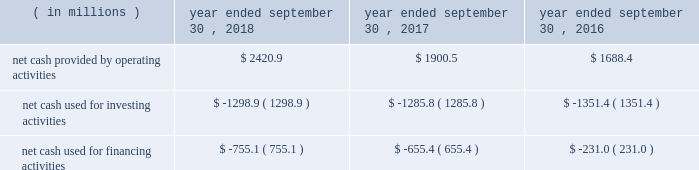Compared to earlier levels .
The pre-tax non-cash impairments of certain mineral rights and real estate discussed above under the caption fffdland and development impairments fffd are not included in segment income .
Liquidity and capital resources on january 29 , 2018 , we announced that a definitive agreement had been signed for us to acquire all of the outstanding shares of kapstone for $ 35.00 per share and the assumption of approximately $ 1.36 billion in net debt , for a total enterprise value of approximately $ 4.9 billion .
In contemplation of the transaction , on march 6 , 2018 , we issued $ 600.0 million aggregate principal amount of 3.75% ( 3.75 % ) senior notes due 2025 and $ 600.0 million aggregate principal amount of 4.0% ( 4.0 % ) senior notes due 2028 in an unregistered offering pursuant to rule 144a and regulation s under the securities act of 1933 , as amended ( the fffdsecurities act fffd ) .
In addition , on march 7 , 2018 , we entered into the delayed draw credit facilities ( as hereinafter defined ) that provide for $ 3.8 billion of senior unsecured term loans .
On november 2 , 2018 , in connection with the closing of the kapstone acquisition , we drew upon the facility in full .
The proceeds of the delayed draw credit facilities ( as hereinafter defined ) and other sources of cash were used to pay the consideration for the kapstone acquisition , to repay certain existing indebtedness of kapstone and to pay fees and expenses incurred in connection with the kapstone acquisition .
We fund our working capital requirements , capital expenditures , mergers , acquisitions and investments , restructuring activities , dividends and stock repurchases from net cash provided by operating activities , borrowings under our credit facilities , proceeds from our new a/r sales agreement ( as hereinafter defined ) , proceeds from the sale of property , plant and equipment removed from service and proceeds received in connection with the issuance of debt and equity securities .
See fffdnote 13 .
Debt fffdtt of the notes to consolidated financial statements for additional information .
Funding for our domestic operations in the foreseeable future is expected to come from sources of liquidity within our domestic operations , including cash and cash equivalents , and available borrowings under our credit facilities .
As such , our foreign cash and cash equivalents are not expected to be a key source of liquidity to our domestic operations .
At september 30 , 2018 , excluding the delayed draw credit facilities , we had approximately $ 3.2 billion of availability under our committed credit facilities , primarily under our revolving credit facility , the majority of which matures on july 1 , 2022 .
This liquidity may be used to provide for ongoing working capital needs and for other general corporate purposes , including acquisitions , dividends and stock repurchases .
Certain restrictive covenants govern our maximum availability under the credit facilities .
We test and report our compliance with these covenants as required and we were in compliance with all of these covenants at september 30 , 2018 .
At september 30 , 2018 , we had $ 104.9 million of outstanding letters of credit not drawn cash and cash equivalents were $ 636.8 million at september 30 , 2018 and $ 298.1 million at september 30 , 2017 .
We used a significant portion of the cash and cash equivalents on hand at september 30 , 2018 in connection with the closing of the kapstone acquisition .
Approximately 20% ( 20 % ) of the cash and cash equivalents at september 30 , 2018 were held outside of the u.s .
At september 30 , 2018 , total debt was $ 6415.2 million , $ 740.7 million of which was current .
At september 30 , 2017 , total debt was $ 6554.8 million , $ 608.7 million of which was current .
Cash flow activityy .
Net cash provided by operating activities during fiscal 2018 increased $ 520.4 million from fiscal 2017 primarily due to higher cash earnings and lower cash taxes due to the impact of the tax act .
Net cash provided by operating activities during fiscal 2017 increased $ 212.1 million from fiscal 2016 primarily due to a $ 111.6 million net increase in cash flow from working capital changes plus higher after-tax cash proceeds from our land and development segment fffds accelerated monetization .
The changes in working capital in fiscal 2018 , 2017 and 2016 included a .
In 2018 , what percent of the net cash from operations is retained after financing and investing activities? 
Computations: ((2420.9 - (1298.9 + 755.1)) / 2420.9)
Answer: 0.15156. 